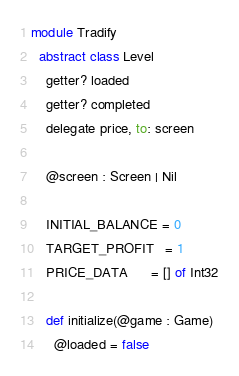Convert code to text. <code><loc_0><loc_0><loc_500><loc_500><_Crystal_>module Tradify
  abstract class Level
    getter? loaded
    getter? completed
    delegate price, to: screen

    @screen : Screen | Nil

    INITIAL_BALANCE = 0
    TARGET_PROFIT   = 1
    PRICE_DATA      = [] of Int32

    def initialize(@game : Game)
      @loaded = false</code> 